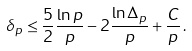<formula> <loc_0><loc_0><loc_500><loc_500>\delta _ { p } \leq \frac { 5 } { 2 } \frac { \ln p } { p } - 2 \frac { \ln \Delta _ { p } } { p } + \frac { C } { p } \, .</formula> 